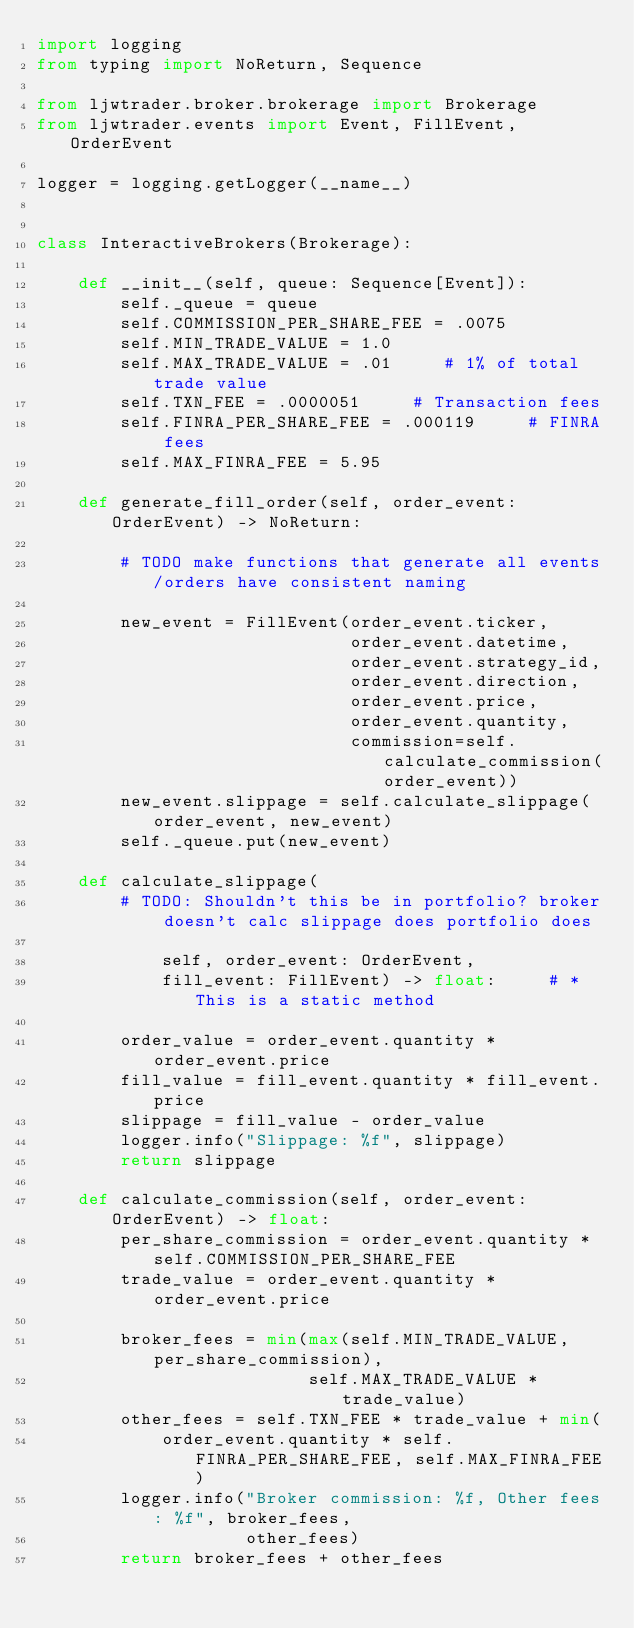Convert code to text. <code><loc_0><loc_0><loc_500><loc_500><_Python_>import logging
from typing import NoReturn, Sequence

from ljwtrader.broker.brokerage import Brokerage
from ljwtrader.events import Event, FillEvent, OrderEvent

logger = logging.getLogger(__name__)


class InteractiveBrokers(Brokerage):

    def __init__(self, queue: Sequence[Event]):
        self._queue = queue
        self.COMMISSION_PER_SHARE_FEE = .0075
        self.MIN_TRADE_VALUE = 1.0
        self.MAX_TRADE_VALUE = .01     # 1% of total trade value
        self.TXN_FEE = .0000051     # Transaction fees
        self.FINRA_PER_SHARE_FEE = .000119     # FINRA fees
        self.MAX_FINRA_FEE = 5.95

    def generate_fill_order(self, order_event: OrderEvent) -> NoReturn:

        # TODO make functions that generate all events/orders have consistent naming

        new_event = FillEvent(order_event.ticker,
                              order_event.datetime,
                              order_event.strategy_id,
                              order_event.direction,
                              order_event.price,
                              order_event.quantity,
                              commission=self.calculate_commission(order_event))
        new_event.slippage = self.calculate_slippage(order_event, new_event)
        self._queue.put(new_event)

    def calculate_slippage(
        # TODO: Shouldn't this be in portfolio? broker doesn't calc slippage does portfolio does

            self, order_event: OrderEvent,
            fill_event: FillEvent) -> float:     # * This is a static method

        order_value = order_event.quantity * order_event.price
        fill_value = fill_event.quantity * fill_event.price
        slippage = fill_value - order_value
        logger.info("Slippage: %f", slippage)
        return slippage

    def calculate_commission(self, order_event: OrderEvent) -> float:
        per_share_commission = order_event.quantity * self.COMMISSION_PER_SHARE_FEE
        trade_value = order_event.quantity * order_event.price

        broker_fees = min(max(self.MIN_TRADE_VALUE, per_share_commission),
                          self.MAX_TRADE_VALUE * trade_value)
        other_fees = self.TXN_FEE * trade_value + min(
            order_event.quantity * self.FINRA_PER_SHARE_FEE, self.MAX_FINRA_FEE)
        logger.info("Broker commission: %f, Other fees: %f", broker_fees,
                    other_fees)
        return broker_fees + other_fees
</code> 